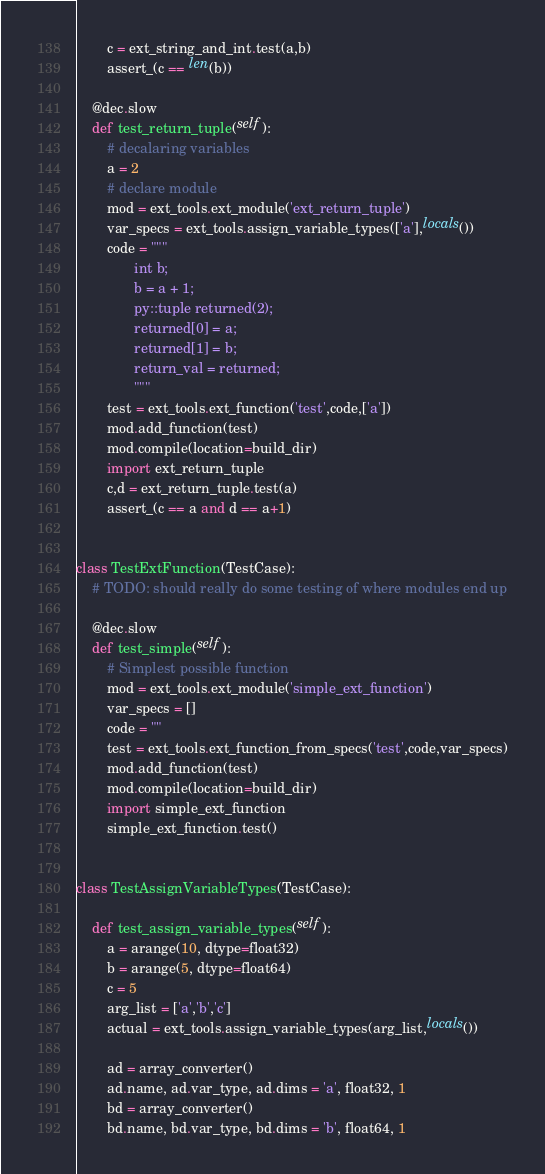<code> <loc_0><loc_0><loc_500><loc_500><_Python_>        c = ext_string_and_int.test(a,b)
        assert_(c == len(b))

    @dec.slow
    def test_return_tuple(self):
        # decalaring variables
        a = 2
        # declare module
        mod = ext_tools.ext_module('ext_return_tuple')
        var_specs = ext_tools.assign_variable_types(['a'],locals())
        code = """
               int b;
               b = a + 1;
               py::tuple returned(2);
               returned[0] = a;
               returned[1] = b;
               return_val = returned;
               """
        test = ext_tools.ext_function('test',code,['a'])
        mod.add_function(test)
        mod.compile(location=build_dir)
        import ext_return_tuple
        c,d = ext_return_tuple.test(a)
        assert_(c == a and d == a+1)


class TestExtFunction(TestCase):
    # TODO: should really do some testing of where modules end up

    @dec.slow
    def test_simple(self):
        # Simplest possible function
        mod = ext_tools.ext_module('simple_ext_function')
        var_specs = []
        code = ""
        test = ext_tools.ext_function_from_specs('test',code,var_specs)
        mod.add_function(test)
        mod.compile(location=build_dir)
        import simple_ext_function
        simple_ext_function.test()


class TestAssignVariableTypes(TestCase):

    def test_assign_variable_types(self):
        a = arange(10, dtype=float32)
        b = arange(5, dtype=float64)
        c = 5
        arg_list = ['a','b','c']
        actual = ext_tools.assign_variable_types(arg_list,locals())

        ad = array_converter()
        ad.name, ad.var_type, ad.dims = 'a', float32, 1
        bd = array_converter()
        bd.name, bd.var_type, bd.dims = 'b', float64, 1
</code> 